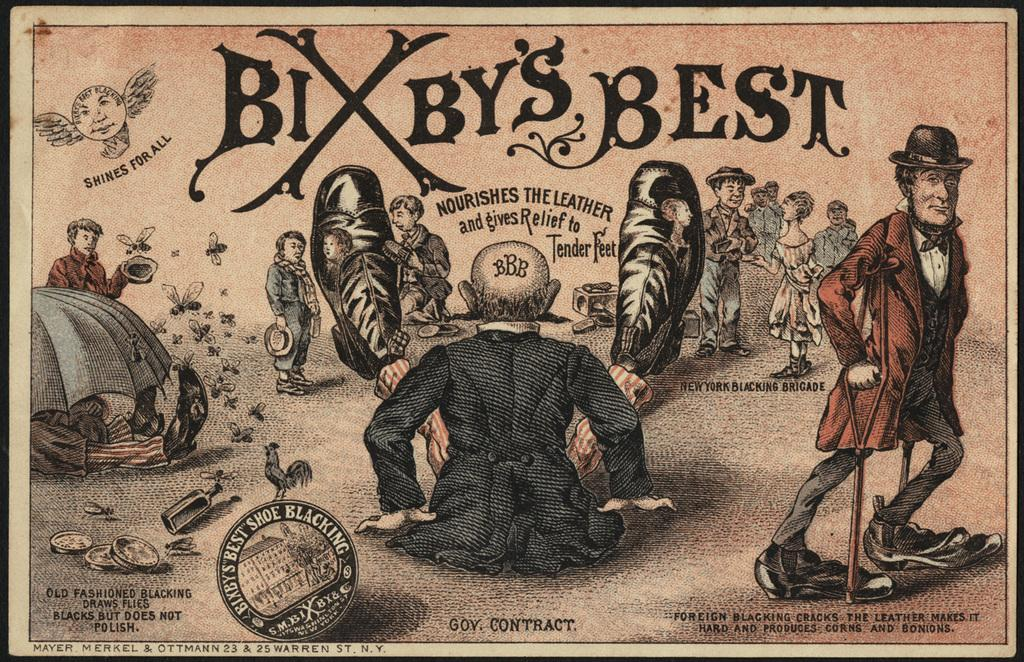What are the people in the image doing? The people in the image are standing and walking on the land. Can you describe any text present in the image? Yes, there is text above and below the scene. What is the position of the man in the image? The man is sitting on the floor in the image. How is the man positioned on the floor? The man is spreading his legs. What type of corn is being harvested in the image? There is no corn present in the image; it features people standing and walking on land, a man sitting on the floor, and text above and below the scene. How much honey is being produced by the bees in the image? There are no bees or honey production depicted in the image. 